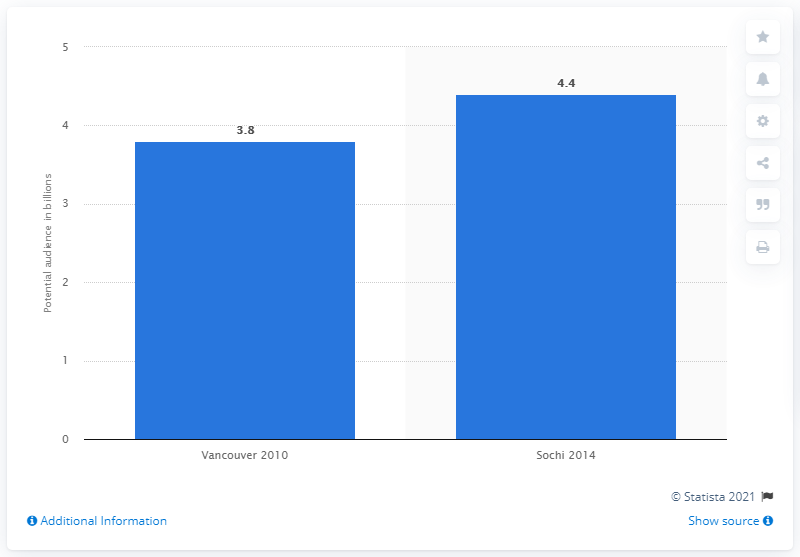Specify some key components in this picture. The potential audience for the Winter Olympics in Sochi was 4.4 million. 